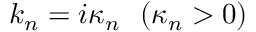<formula> <loc_0><loc_0><loc_500><loc_500>k _ { n } = i \kappa _ { n } ( \kappa _ { n } > 0 )</formula> 